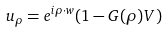Convert formula to latex. <formula><loc_0><loc_0><loc_500><loc_500>u _ { \rho } = e ^ { i \rho \cdot w } ( 1 - G ( \rho ) V )</formula> 